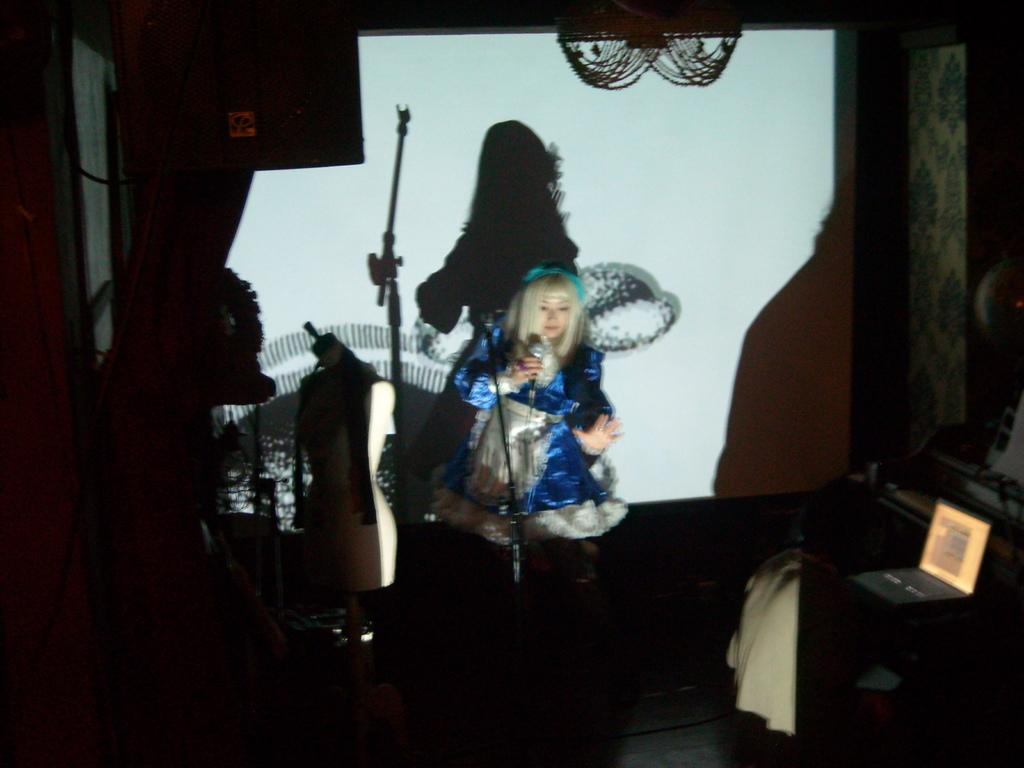Who is the main subject in the image? There is a woman in the image. What is the woman doing in the image? The woman is singing. Can you describe the lighting in the image? There is a light focused on the woman. What type of grain is being harvested in the background of the image? There is no grain or harvesting activity present in the image; it features a woman singing with a focused light on her. 